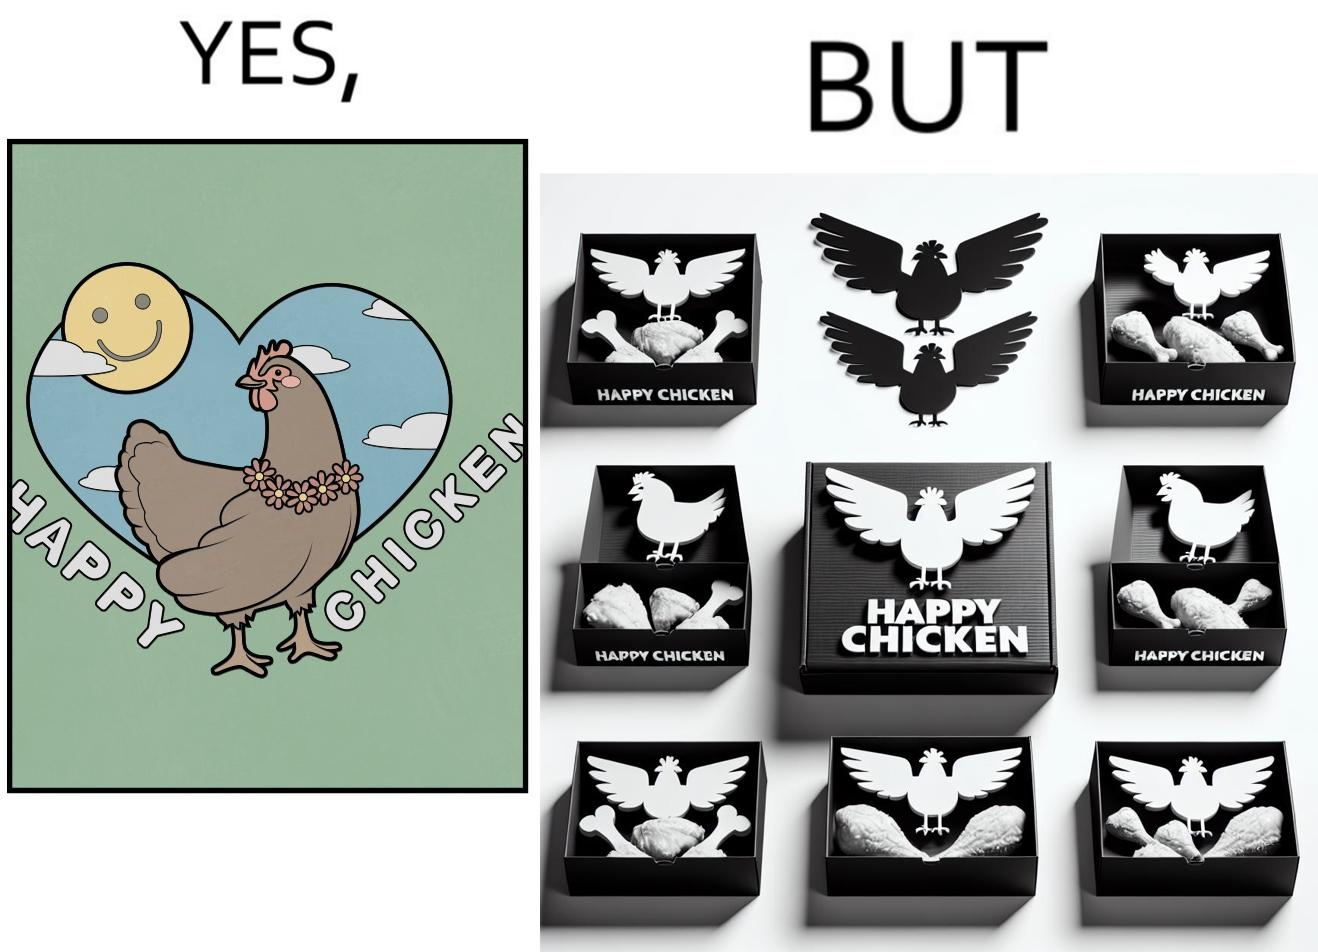Describe what you see in the left and right parts of this image. In the left part of the image: a chicken with a quote "HAPPY CHICKEN" in the background In the right part of the image: chicken pieces packed in boxes with a logo of a chicken with name "HAPPY CHICKEN" printed on it 